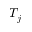Convert formula to latex. <formula><loc_0><loc_0><loc_500><loc_500>T _ { j }</formula> 